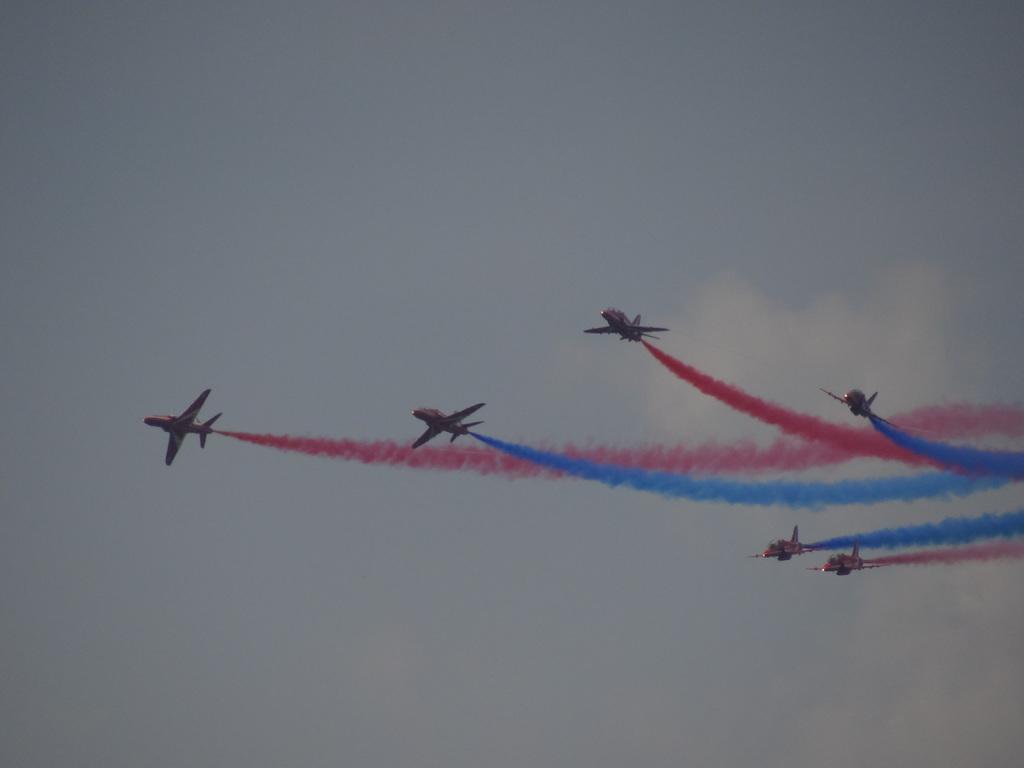Describe this image in one or two sentences. We can see airplanes and smoke in the air. We can see sky with clouds. 